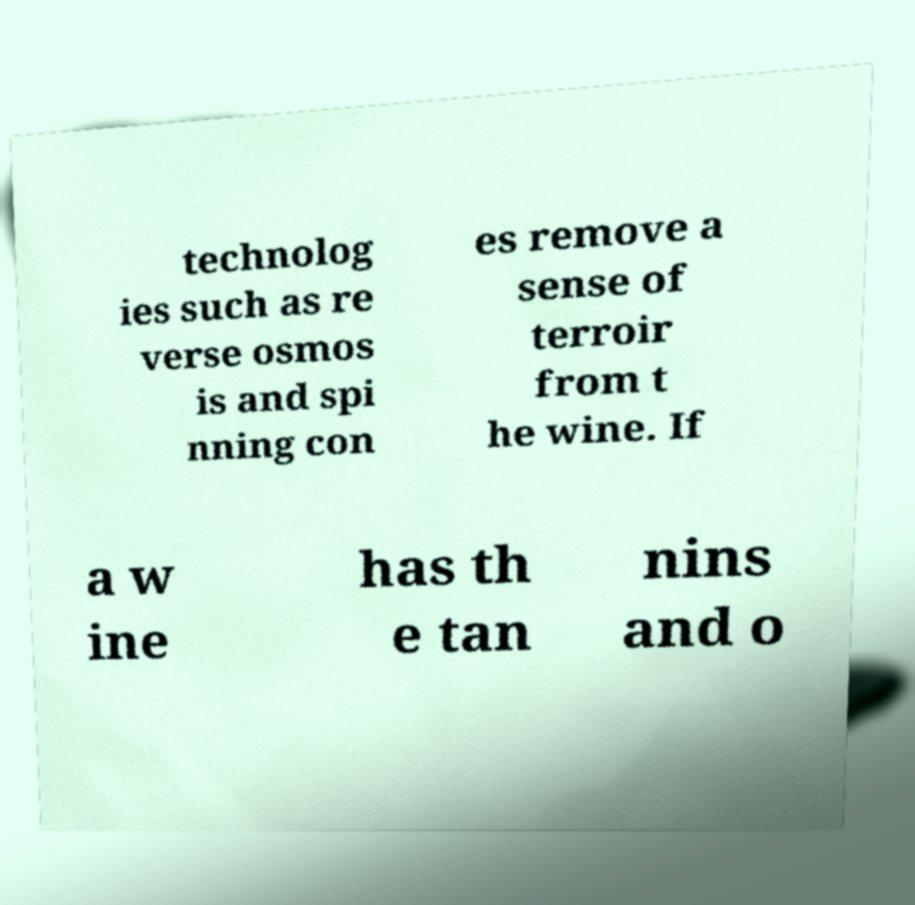There's text embedded in this image that I need extracted. Can you transcribe it verbatim? technolog ies such as re verse osmos is and spi nning con es remove a sense of terroir from t he wine. If a w ine has th e tan nins and o 